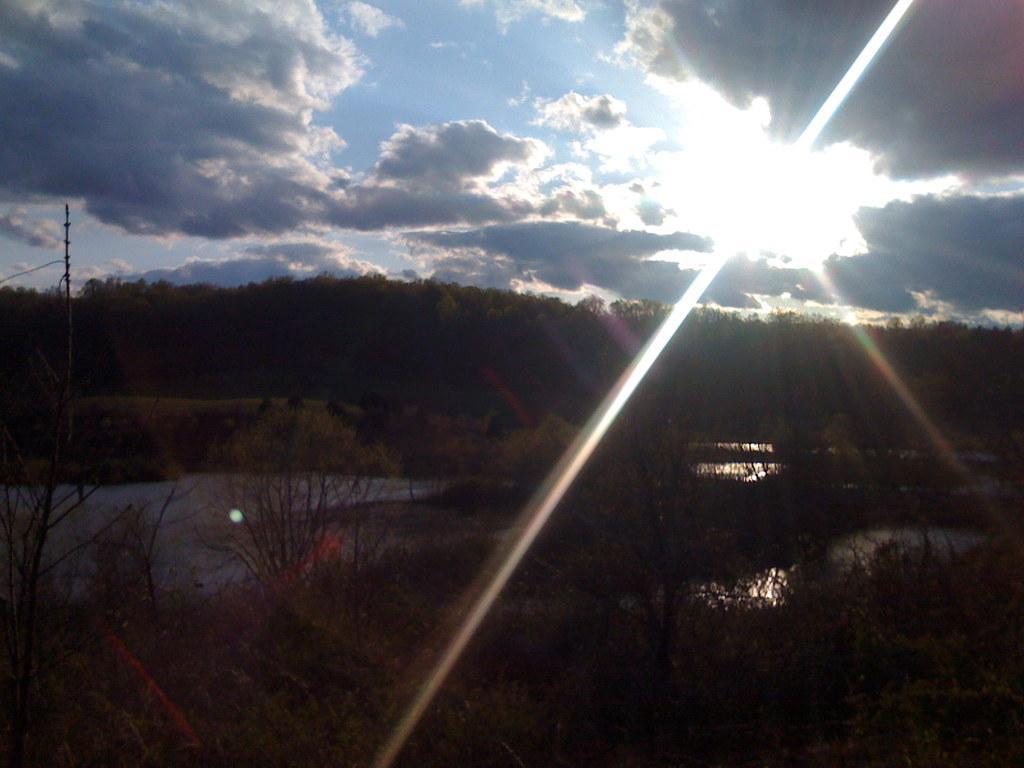Please provide a concise description of this image. In this picture we can see water, trees, pole and in the background we can see sky with clouds. 